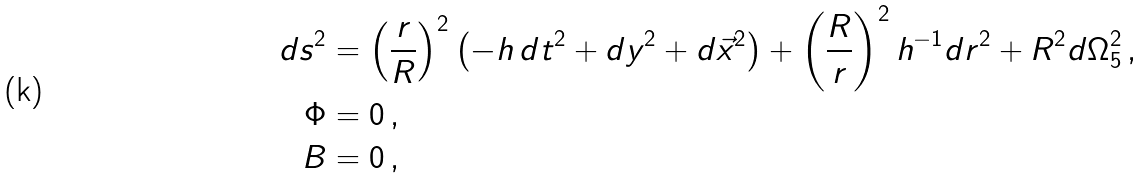<formula> <loc_0><loc_0><loc_500><loc_500>d s ^ { 2 } & = \left ( \frac { r } { R } \right ) ^ { 2 } \left ( - h \, d t ^ { 2 } + d y ^ { 2 } + d \vec { x } ^ { 2 } \right ) + \left ( \frac { R } { r } \right ) ^ { 2 } h ^ { - 1 } d r ^ { 2 } + R ^ { 2 } d \Omega _ { 5 } ^ { 2 } \, , \\ \Phi & = 0 \, , \\ B & = 0 \, ,</formula> 